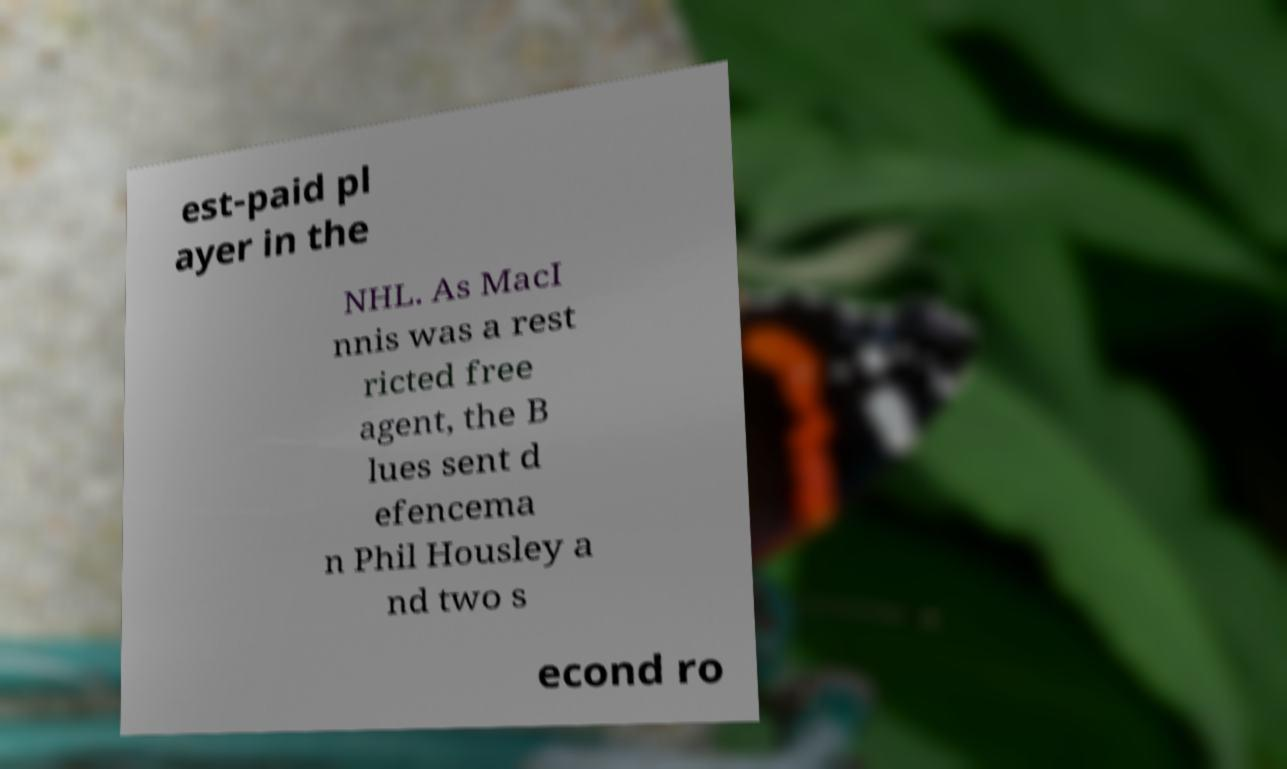I need the written content from this picture converted into text. Can you do that? est-paid pl ayer in the NHL. As MacI nnis was a rest ricted free agent, the B lues sent d efencema n Phil Housley a nd two s econd ro 